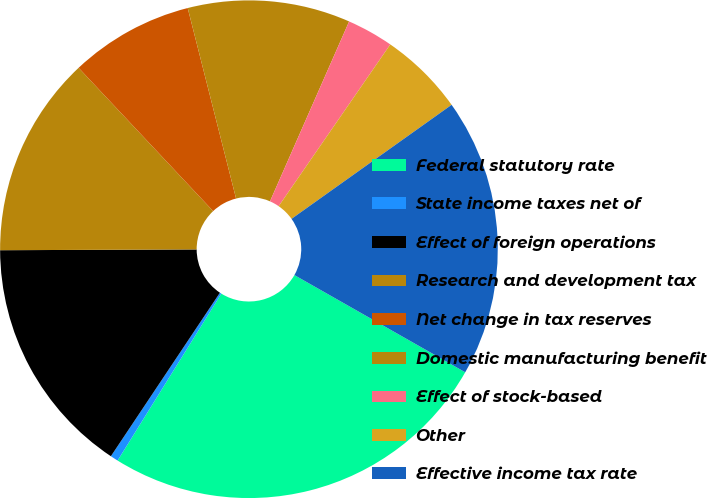<chart> <loc_0><loc_0><loc_500><loc_500><pie_chart><fcel>Federal statutory rate<fcel>State income taxes net of<fcel>Effect of foreign operations<fcel>Research and development tax<fcel>Net change in tax reserves<fcel>Domestic manufacturing benefit<fcel>Effect of stock-based<fcel>Other<fcel>Effective income tax rate<nl><fcel>25.61%<fcel>0.51%<fcel>15.57%<fcel>13.06%<fcel>8.04%<fcel>10.55%<fcel>3.02%<fcel>5.53%<fcel>18.08%<nl></chart> 